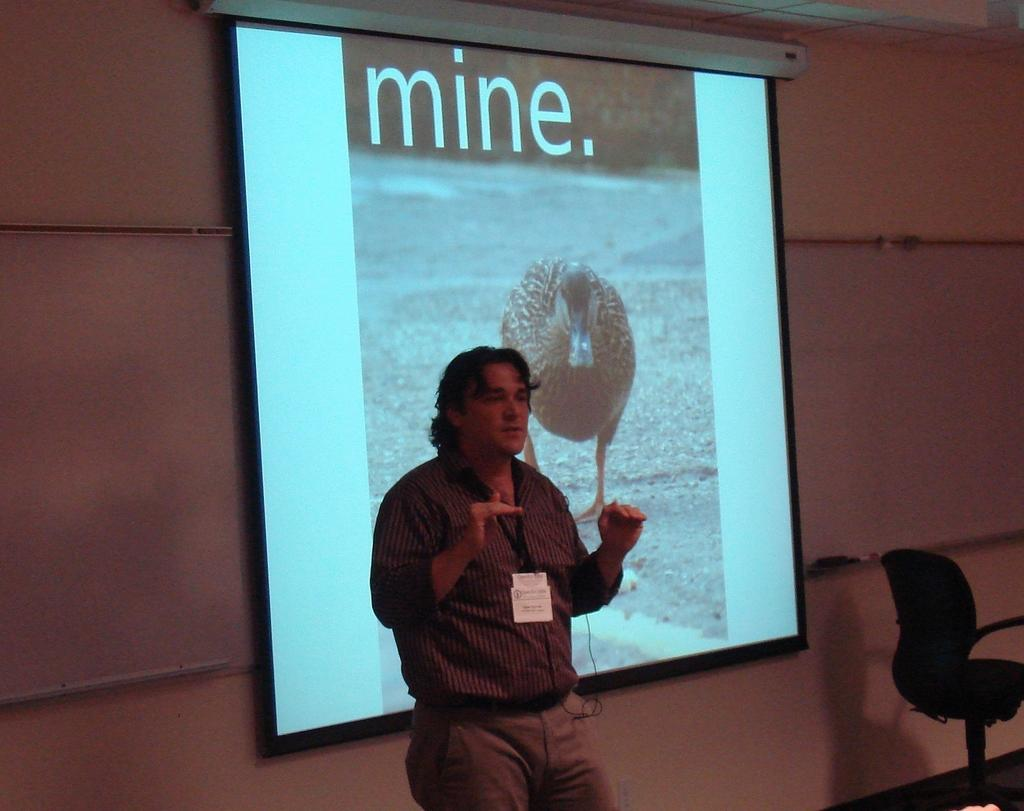Who is present in the image? There is a man in the image. What is the man standing next to? The man is standing next to a projector screen. Can you describe any furniture in the image? There is a chair in the image. What fact is being presented on the elbow of the man in the image? There is no fact being presented on the elbow of the man in the image, as elbows are not typically used for presenting information. 